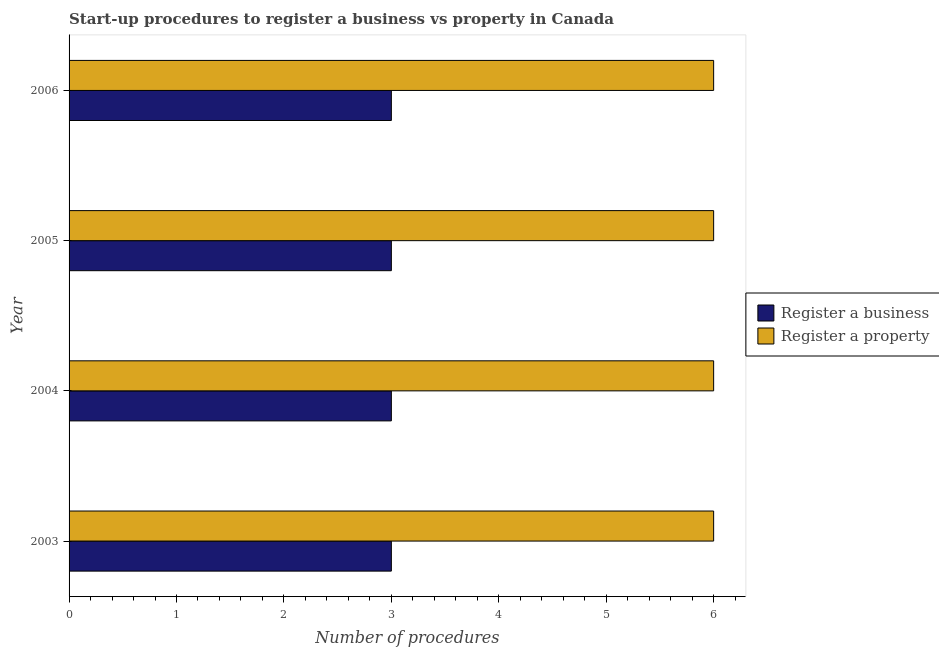How many different coloured bars are there?
Provide a succinct answer. 2. How many groups of bars are there?
Offer a very short reply. 4. How many bars are there on the 1st tick from the top?
Keep it short and to the point. 2. How many bars are there on the 3rd tick from the bottom?
Make the answer very short. 2. In how many cases, is the number of bars for a given year not equal to the number of legend labels?
Your response must be concise. 0. Across all years, what is the maximum number of procedures to register a business?
Keep it short and to the point. 3. In which year was the number of procedures to register a property minimum?
Offer a terse response. 2003. What is the total number of procedures to register a business in the graph?
Make the answer very short. 12. What is the difference between the number of procedures to register a property in 2005 and that in 2006?
Keep it short and to the point. 0. What is the difference between the number of procedures to register a property in 2003 and the number of procedures to register a business in 2006?
Ensure brevity in your answer.  3. What is the average number of procedures to register a business per year?
Offer a very short reply. 3. In the year 2003, what is the difference between the number of procedures to register a business and number of procedures to register a property?
Offer a very short reply. -3. What is the difference between the highest and the second highest number of procedures to register a business?
Your answer should be compact. 0. What is the difference between the highest and the lowest number of procedures to register a property?
Make the answer very short. 0. Is the sum of the number of procedures to register a business in 2005 and 2006 greater than the maximum number of procedures to register a property across all years?
Your response must be concise. No. What does the 1st bar from the top in 2003 represents?
Ensure brevity in your answer.  Register a property. What does the 1st bar from the bottom in 2003 represents?
Your answer should be very brief. Register a business. How many years are there in the graph?
Provide a short and direct response. 4. What is the difference between two consecutive major ticks on the X-axis?
Provide a succinct answer. 1. Are the values on the major ticks of X-axis written in scientific E-notation?
Offer a very short reply. No. Does the graph contain any zero values?
Provide a succinct answer. No. Does the graph contain grids?
Offer a terse response. No. What is the title of the graph?
Your answer should be compact. Start-up procedures to register a business vs property in Canada. What is the label or title of the X-axis?
Your answer should be very brief. Number of procedures. What is the Number of procedures in Register a business in 2003?
Your answer should be very brief. 3. What is the Number of procedures of Register a property in 2003?
Keep it short and to the point. 6. What is the Number of procedures of Register a business in 2005?
Make the answer very short. 3. What is the Number of procedures of Register a property in 2005?
Offer a very short reply. 6. What is the Number of procedures in Register a property in 2006?
Your response must be concise. 6. Across all years, what is the maximum Number of procedures of Register a business?
Offer a very short reply. 3. Across all years, what is the minimum Number of procedures in Register a business?
Your answer should be very brief. 3. What is the total Number of procedures in Register a business in the graph?
Your answer should be very brief. 12. What is the total Number of procedures of Register a property in the graph?
Your answer should be very brief. 24. What is the difference between the Number of procedures of Register a business in 2003 and that in 2004?
Make the answer very short. 0. What is the difference between the Number of procedures in Register a property in 2003 and that in 2004?
Provide a short and direct response. 0. What is the difference between the Number of procedures of Register a property in 2003 and that in 2005?
Your answer should be compact. 0. What is the difference between the Number of procedures of Register a business in 2003 and that in 2006?
Your response must be concise. 0. What is the difference between the Number of procedures in Register a property in 2003 and that in 2006?
Provide a succinct answer. 0. What is the difference between the Number of procedures of Register a property in 2004 and that in 2005?
Ensure brevity in your answer.  0. What is the difference between the Number of procedures of Register a business in 2004 and that in 2006?
Ensure brevity in your answer.  0. What is the difference between the Number of procedures in Register a business in 2005 and that in 2006?
Give a very brief answer. 0. What is the difference between the Number of procedures of Register a property in 2005 and that in 2006?
Your answer should be very brief. 0. What is the difference between the Number of procedures of Register a business in 2003 and the Number of procedures of Register a property in 2004?
Offer a very short reply. -3. What is the difference between the Number of procedures of Register a business in 2003 and the Number of procedures of Register a property in 2005?
Your response must be concise. -3. What is the difference between the Number of procedures of Register a business in 2003 and the Number of procedures of Register a property in 2006?
Ensure brevity in your answer.  -3. What is the difference between the Number of procedures of Register a business in 2005 and the Number of procedures of Register a property in 2006?
Your answer should be very brief. -3. What is the average Number of procedures of Register a business per year?
Your answer should be very brief. 3. What is the average Number of procedures of Register a property per year?
Your answer should be compact. 6. In the year 2003, what is the difference between the Number of procedures in Register a business and Number of procedures in Register a property?
Make the answer very short. -3. In the year 2005, what is the difference between the Number of procedures of Register a business and Number of procedures of Register a property?
Provide a short and direct response. -3. In the year 2006, what is the difference between the Number of procedures of Register a business and Number of procedures of Register a property?
Ensure brevity in your answer.  -3. What is the ratio of the Number of procedures of Register a business in 2003 to that in 2004?
Offer a terse response. 1. What is the ratio of the Number of procedures of Register a property in 2003 to that in 2004?
Keep it short and to the point. 1. What is the ratio of the Number of procedures in Register a property in 2003 to that in 2006?
Give a very brief answer. 1. What is the ratio of the Number of procedures in Register a property in 2004 to that in 2005?
Your answer should be very brief. 1. What is the ratio of the Number of procedures in Register a business in 2004 to that in 2006?
Make the answer very short. 1. What is the ratio of the Number of procedures of Register a business in 2005 to that in 2006?
Your answer should be very brief. 1. What is the ratio of the Number of procedures in Register a property in 2005 to that in 2006?
Your response must be concise. 1. What is the difference between the highest and the lowest Number of procedures of Register a property?
Your answer should be very brief. 0. 